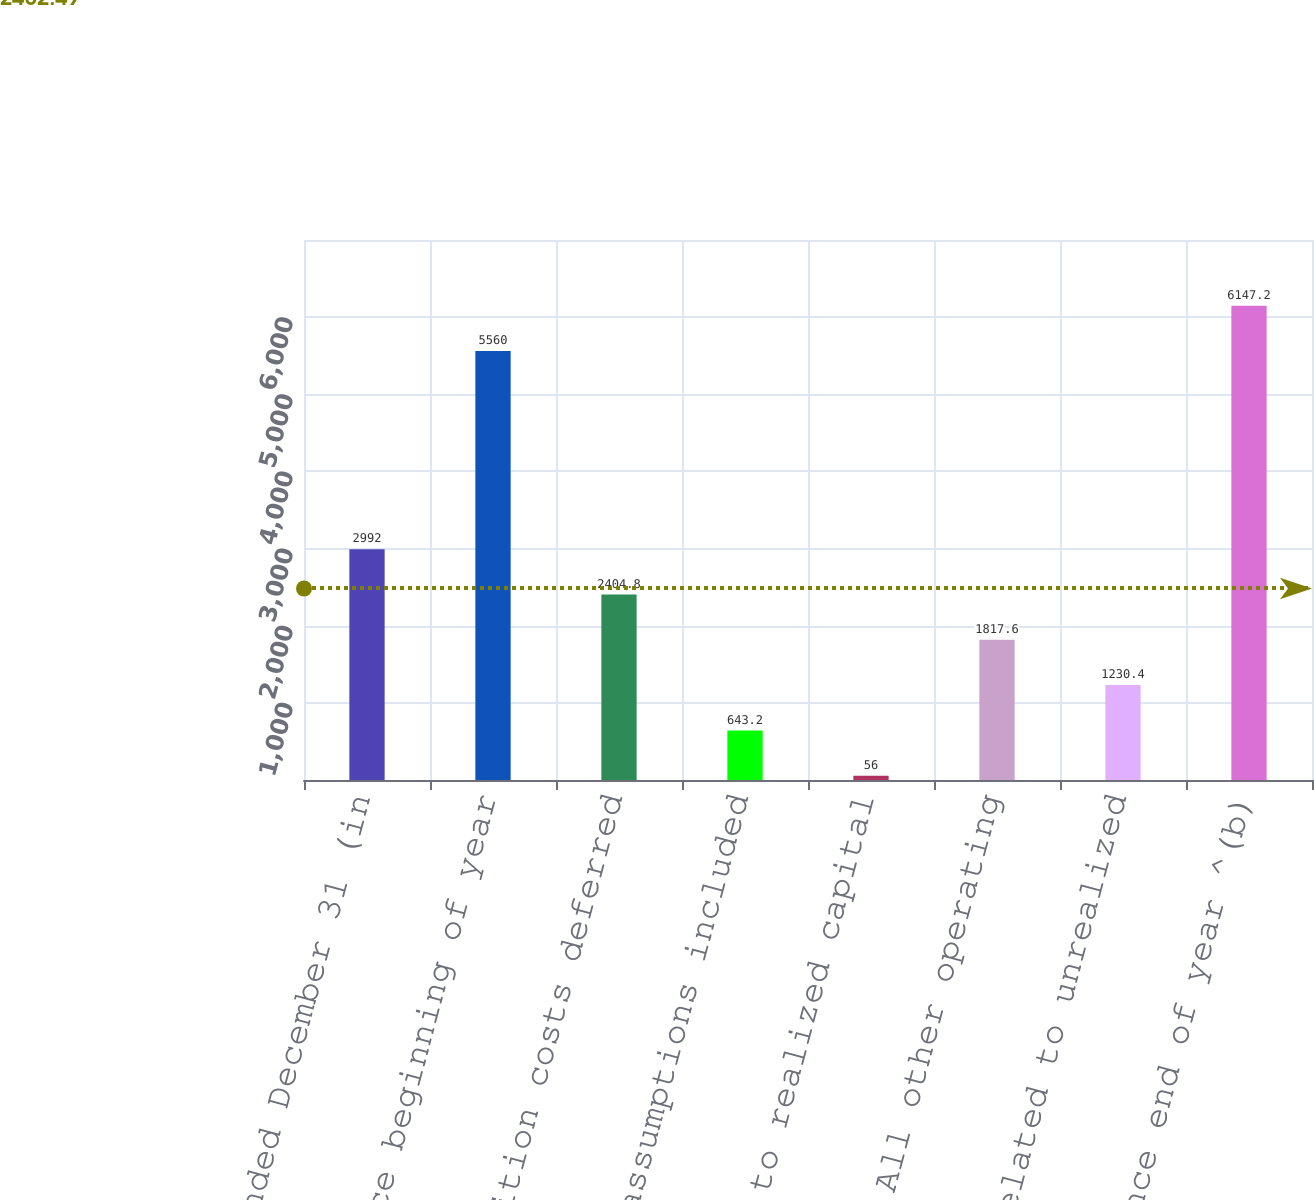<chart> <loc_0><loc_0><loc_500><loc_500><bar_chart><fcel>Years Ended December 31 (in<fcel>Balance beginning of year<fcel>Acquisition costs deferred<fcel>Update of assumptions included<fcel>Related to realized capital<fcel>All other operating<fcel>Change related to unrealized<fcel>Balance end of year ^(b)<nl><fcel>2992<fcel>5560<fcel>2404.8<fcel>643.2<fcel>56<fcel>1817.6<fcel>1230.4<fcel>6147.2<nl></chart> 